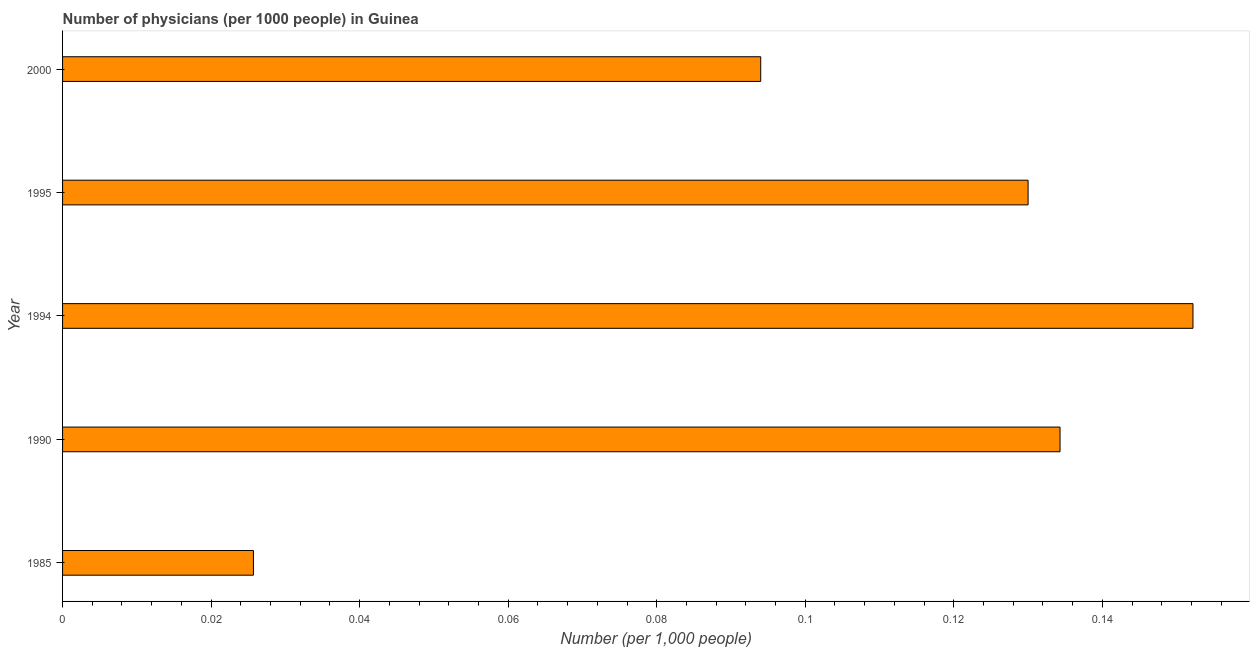What is the title of the graph?
Provide a short and direct response. Number of physicians (per 1000 people) in Guinea. What is the label or title of the X-axis?
Offer a very short reply. Number (per 1,0 people). What is the label or title of the Y-axis?
Offer a terse response. Year. What is the number of physicians in 1994?
Make the answer very short. 0.15. Across all years, what is the maximum number of physicians?
Your response must be concise. 0.15. Across all years, what is the minimum number of physicians?
Make the answer very short. 0.03. In which year was the number of physicians minimum?
Your response must be concise. 1985. What is the sum of the number of physicians?
Make the answer very short. 0.54. What is the difference between the number of physicians in 1985 and 1990?
Make the answer very short. -0.11. What is the average number of physicians per year?
Provide a short and direct response. 0.11. What is the median number of physicians?
Provide a short and direct response. 0.13. What is the ratio of the number of physicians in 1994 to that in 2000?
Your answer should be very brief. 1.62. Is the number of physicians in 1994 less than that in 2000?
Your answer should be compact. No. Is the difference between the number of physicians in 1985 and 1994 greater than the difference between any two years?
Ensure brevity in your answer.  Yes. What is the difference between the highest and the second highest number of physicians?
Make the answer very short. 0.02. Is the sum of the number of physicians in 1994 and 2000 greater than the maximum number of physicians across all years?
Provide a short and direct response. Yes. What is the difference between the highest and the lowest number of physicians?
Make the answer very short. 0.13. In how many years, is the number of physicians greater than the average number of physicians taken over all years?
Give a very brief answer. 3. How many bars are there?
Ensure brevity in your answer.  5. Are all the bars in the graph horizontal?
Give a very brief answer. Yes. What is the difference between two consecutive major ticks on the X-axis?
Make the answer very short. 0.02. What is the Number (per 1,000 people) of 1985?
Offer a terse response. 0.03. What is the Number (per 1,000 people) of 1990?
Provide a succinct answer. 0.13. What is the Number (per 1,000 people) in 1994?
Keep it short and to the point. 0.15. What is the Number (per 1,000 people) in 1995?
Keep it short and to the point. 0.13. What is the Number (per 1,000 people) in 2000?
Offer a very short reply. 0.09. What is the difference between the Number (per 1,000 people) in 1985 and 1990?
Make the answer very short. -0.11. What is the difference between the Number (per 1,000 people) in 1985 and 1994?
Your answer should be very brief. -0.13. What is the difference between the Number (per 1,000 people) in 1985 and 1995?
Your answer should be compact. -0.1. What is the difference between the Number (per 1,000 people) in 1985 and 2000?
Your answer should be compact. -0.07. What is the difference between the Number (per 1,000 people) in 1990 and 1994?
Keep it short and to the point. -0.02. What is the difference between the Number (per 1,000 people) in 1990 and 1995?
Offer a terse response. 0. What is the difference between the Number (per 1,000 people) in 1990 and 2000?
Your response must be concise. 0.04. What is the difference between the Number (per 1,000 people) in 1994 and 1995?
Offer a very short reply. 0.02. What is the difference between the Number (per 1,000 people) in 1994 and 2000?
Give a very brief answer. 0.06. What is the difference between the Number (per 1,000 people) in 1995 and 2000?
Your answer should be very brief. 0.04. What is the ratio of the Number (per 1,000 people) in 1985 to that in 1990?
Your answer should be compact. 0.19. What is the ratio of the Number (per 1,000 people) in 1985 to that in 1994?
Give a very brief answer. 0.17. What is the ratio of the Number (per 1,000 people) in 1985 to that in 1995?
Your answer should be very brief. 0.2. What is the ratio of the Number (per 1,000 people) in 1985 to that in 2000?
Offer a terse response. 0.27. What is the ratio of the Number (per 1,000 people) in 1990 to that in 1994?
Offer a very short reply. 0.88. What is the ratio of the Number (per 1,000 people) in 1990 to that in 1995?
Make the answer very short. 1.03. What is the ratio of the Number (per 1,000 people) in 1990 to that in 2000?
Offer a terse response. 1.43. What is the ratio of the Number (per 1,000 people) in 1994 to that in 1995?
Your answer should be compact. 1.17. What is the ratio of the Number (per 1,000 people) in 1994 to that in 2000?
Offer a terse response. 1.62. What is the ratio of the Number (per 1,000 people) in 1995 to that in 2000?
Ensure brevity in your answer.  1.38. 